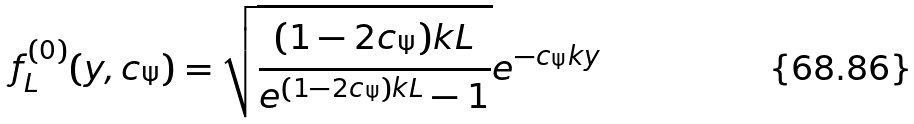Convert formula to latex. <formula><loc_0><loc_0><loc_500><loc_500>f _ { L } ^ { ( 0 ) } ( y , c _ { \Psi } ) = \sqrt { \frac { ( 1 - 2 c _ { \Psi } ) k L } { e ^ { ( 1 - 2 c _ { \Psi } ) k L } - 1 } } e ^ { - c _ { \Psi } k y }</formula> 